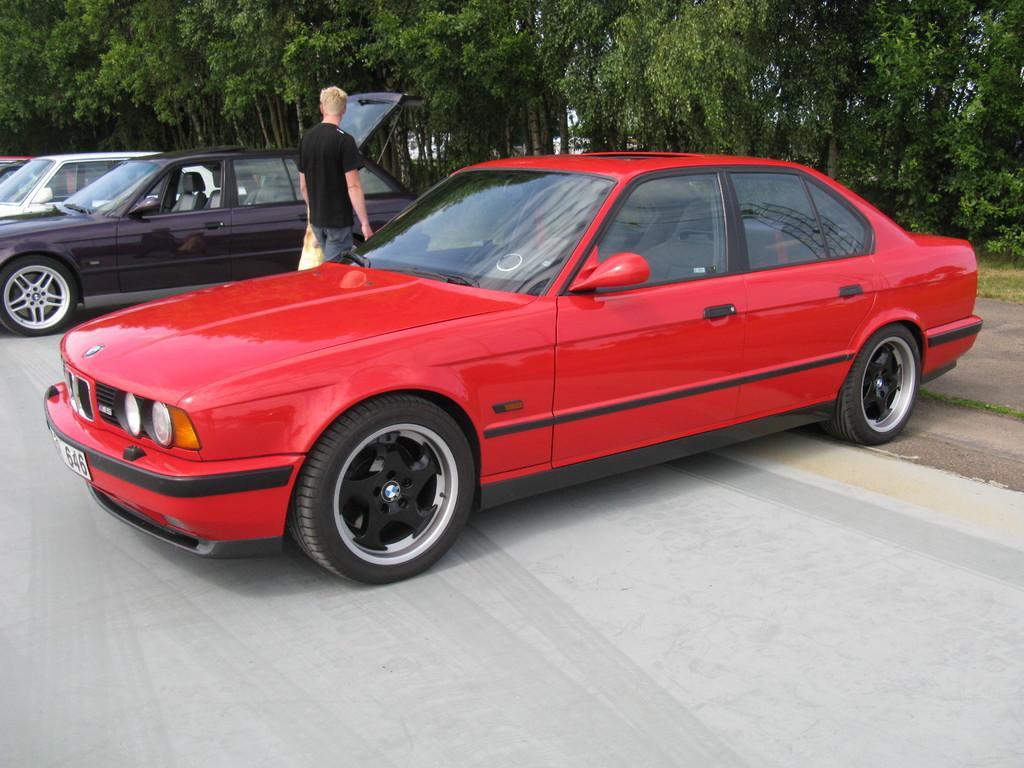Could you give a brief overview of what you see in this image? In this image there are cars on the road. Beside the cars there is a person standing by holding the cover. At the background there are trees. 